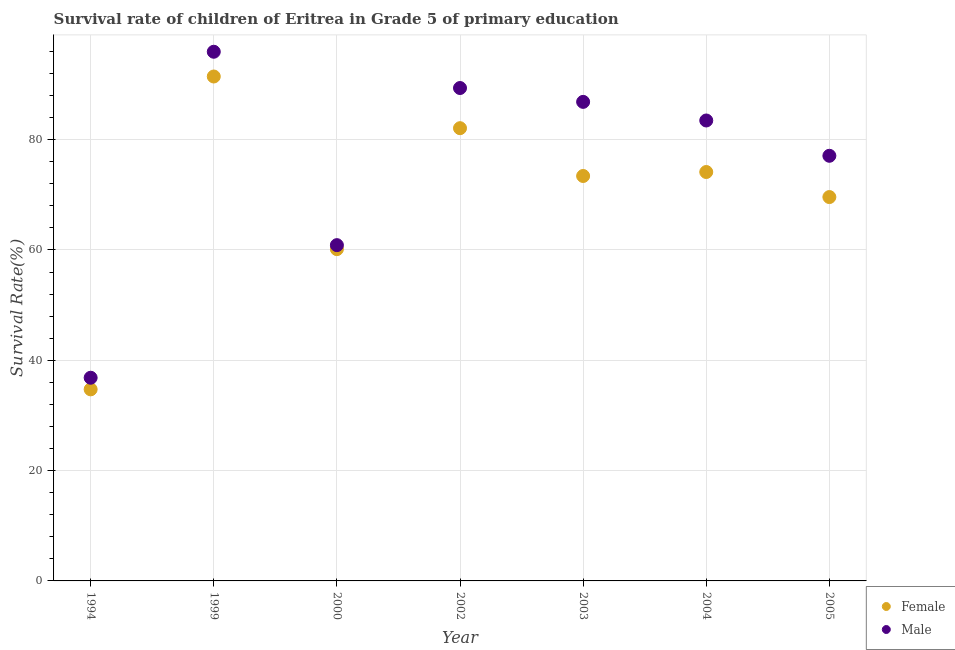What is the survival rate of female students in primary education in 2004?
Give a very brief answer. 74.13. Across all years, what is the maximum survival rate of male students in primary education?
Offer a terse response. 95.94. Across all years, what is the minimum survival rate of male students in primary education?
Your response must be concise. 36.84. What is the total survival rate of male students in primary education in the graph?
Offer a terse response. 530.41. What is the difference between the survival rate of male students in primary education in 2003 and that in 2005?
Provide a short and direct response. 9.77. What is the difference between the survival rate of female students in primary education in 2003 and the survival rate of male students in primary education in 1994?
Your answer should be compact. 36.58. What is the average survival rate of female students in primary education per year?
Provide a succinct answer. 69.36. In the year 1994, what is the difference between the survival rate of female students in primary education and survival rate of male students in primary education?
Provide a succinct answer. -2.1. In how many years, is the survival rate of male students in primary education greater than 12 %?
Your response must be concise. 7. What is the ratio of the survival rate of male students in primary education in 1994 to that in 2003?
Keep it short and to the point. 0.42. Is the difference between the survival rate of male students in primary education in 2000 and 2003 greater than the difference between the survival rate of female students in primary education in 2000 and 2003?
Your response must be concise. No. What is the difference between the highest and the second highest survival rate of male students in primary education?
Make the answer very short. 6.58. What is the difference between the highest and the lowest survival rate of female students in primary education?
Provide a short and direct response. 56.72. How many dotlines are there?
Provide a succinct answer. 2. How many years are there in the graph?
Provide a short and direct response. 7. What is the difference between two consecutive major ticks on the Y-axis?
Offer a very short reply. 20. Does the graph contain grids?
Ensure brevity in your answer.  Yes. How many legend labels are there?
Ensure brevity in your answer.  2. How are the legend labels stacked?
Offer a terse response. Vertical. What is the title of the graph?
Provide a short and direct response. Survival rate of children of Eritrea in Grade 5 of primary education. Does "Techinal cooperation" appear as one of the legend labels in the graph?
Provide a short and direct response. No. What is the label or title of the X-axis?
Provide a succinct answer. Year. What is the label or title of the Y-axis?
Give a very brief answer. Survival Rate(%). What is the Survival Rate(%) of Female in 1994?
Make the answer very short. 34.73. What is the Survival Rate(%) in Male in 1994?
Keep it short and to the point. 36.84. What is the Survival Rate(%) of Female in 1999?
Your response must be concise. 91.45. What is the Survival Rate(%) in Male in 1999?
Your answer should be very brief. 95.94. What is the Survival Rate(%) of Female in 2000?
Offer a very short reply. 60.15. What is the Survival Rate(%) in Male in 2000?
Your answer should be very brief. 60.88. What is the Survival Rate(%) of Female in 2002?
Ensure brevity in your answer.  82.08. What is the Survival Rate(%) of Male in 2002?
Provide a succinct answer. 89.36. What is the Survival Rate(%) in Female in 2003?
Provide a short and direct response. 73.41. What is the Survival Rate(%) in Male in 2003?
Offer a terse response. 86.85. What is the Survival Rate(%) in Female in 2004?
Offer a very short reply. 74.13. What is the Survival Rate(%) in Male in 2004?
Provide a short and direct response. 83.48. What is the Survival Rate(%) of Female in 2005?
Give a very brief answer. 69.59. What is the Survival Rate(%) of Male in 2005?
Your response must be concise. 77.08. Across all years, what is the maximum Survival Rate(%) in Female?
Make the answer very short. 91.45. Across all years, what is the maximum Survival Rate(%) of Male?
Make the answer very short. 95.94. Across all years, what is the minimum Survival Rate(%) in Female?
Offer a very short reply. 34.73. Across all years, what is the minimum Survival Rate(%) of Male?
Provide a short and direct response. 36.84. What is the total Survival Rate(%) in Female in the graph?
Give a very brief answer. 485.55. What is the total Survival Rate(%) of Male in the graph?
Ensure brevity in your answer.  530.41. What is the difference between the Survival Rate(%) of Female in 1994 and that in 1999?
Offer a terse response. -56.72. What is the difference between the Survival Rate(%) in Male in 1994 and that in 1999?
Provide a succinct answer. -59.1. What is the difference between the Survival Rate(%) of Female in 1994 and that in 2000?
Keep it short and to the point. -25.42. What is the difference between the Survival Rate(%) of Male in 1994 and that in 2000?
Offer a very short reply. -24.04. What is the difference between the Survival Rate(%) of Female in 1994 and that in 2002?
Your answer should be compact. -47.35. What is the difference between the Survival Rate(%) of Male in 1994 and that in 2002?
Ensure brevity in your answer.  -52.53. What is the difference between the Survival Rate(%) of Female in 1994 and that in 2003?
Your answer should be very brief. -38.68. What is the difference between the Survival Rate(%) of Male in 1994 and that in 2003?
Offer a terse response. -50.01. What is the difference between the Survival Rate(%) in Female in 1994 and that in 2004?
Make the answer very short. -39.4. What is the difference between the Survival Rate(%) in Male in 1994 and that in 2004?
Offer a very short reply. -46.64. What is the difference between the Survival Rate(%) in Female in 1994 and that in 2005?
Your answer should be very brief. -34.86. What is the difference between the Survival Rate(%) of Male in 1994 and that in 2005?
Your response must be concise. -40.24. What is the difference between the Survival Rate(%) of Female in 1999 and that in 2000?
Provide a short and direct response. 31.3. What is the difference between the Survival Rate(%) of Male in 1999 and that in 2000?
Ensure brevity in your answer.  35.06. What is the difference between the Survival Rate(%) in Female in 1999 and that in 2002?
Provide a succinct answer. 9.37. What is the difference between the Survival Rate(%) of Male in 1999 and that in 2002?
Your response must be concise. 6.58. What is the difference between the Survival Rate(%) of Female in 1999 and that in 2003?
Provide a short and direct response. 18.04. What is the difference between the Survival Rate(%) of Male in 1999 and that in 2003?
Your answer should be very brief. 9.09. What is the difference between the Survival Rate(%) of Female in 1999 and that in 2004?
Your answer should be compact. 17.32. What is the difference between the Survival Rate(%) of Male in 1999 and that in 2004?
Your response must be concise. 12.46. What is the difference between the Survival Rate(%) in Female in 1999 and that in 2005?
Ensure brevity in your answer.  21.86. What is the difference between the Survival Rate(%) in Male in 1999 and that in 2005?
Your answer should be very brief. 18.86. What is the difference between the Survival Rate(%) of Female in 2000 and that in 2002?
Offer a very short reply. -21.93. What is the difference between the Survival Rate(%) of Male in 2000 and that in 2002?
Offer a very short reply. -28.49. What is the difference between the Survival Rate(%) of Female in 2000 and that in 2003?
Keep it short and to the point. -13.26. What is the difference between the Survival Rate(%) in Male in 2000 and that in 2003?
Keep it short and to the point. -25.97. What is the difference between the Survival Rate(%) of Female in 2000 and that in 2004?
Provide a succinct answer. -13.98. What is the difference between the Survival Rate(%) of Male in 2000 and that in 2004?
Provide a short and direct response. -22.6. What is the difference between the Survival Rate(%) in Female in 2000 and that in 2005?
Your answer should be compact. -9.44. What is the difference between the Survival Rate(%) in Male in 2000 and that in 2005?
Keep it short and to the point. -16.2. What is the difference between the Survival Rate(%) in Female in 2002 and that in 2003?
Provide a succinct answer. 8.67. What is the difference between the Survival Rate(%) of Male in 2002 and that in 2003?
Ensure brevity in your answer.  2.51. What is the difference between the Survival Rate(%) in Female in 2002 and that in 2004?
Make the answer very short. 7.95. What is the difference between the Survival Rate(%) in Male in 2002 and that in 2004?
Your answer should be very brief. 5.89. What is the difference between the Survival Rate(%) in Female in 2002 and that in 2005?
Your response must be concise. 12.49. What is the difference between the Survival Rate(%) in Male in 2002 and that in 2005?
Your response must be concise. 12.29. What is the difference between the Survival Rate(%) of Female in 2003 and that in 2004?
Your response must be concise. -0.72. What is the difference between the Survival Rate(%) of Male in 2003 and that in 2004?
Ensure brevity in your answer.  3.37. What is the difference between the Survival Rate(%) of Female in 2003 and that in 2005?
Provide a succinct answer. 3.82. What is the difference between the Survival Rate(%) in Male in 2003 and that in 2005?
Give a very brief answer. 9.77. What is the difference between the Survival Rate(%) of Female in 2004 and that in 2005?
Offer a terse response. 4.54. What is the difference between the Survival Rate(%) in Male in 2004 and that in 2005?
Your response must be concise. 6.4. What is the difference between the Survival Rate(%) of Female in 1994 and the Survival Rate(%) of Male in 1999?
Ensure brevity in your answer.  -61.2. What is the difference between the Survival Rate(%) in Female in 1994 and the Survival Rate(%) in Male in 2000?
Provide a short and direct response. -26.14. What is the difference between the Survival Rate(%) in Female in 1994 and the Survival Rate(%) in Male in 2002?
Give a very brief answer. -54.63. What is the difference between the Survival Rate(%) of Female in 1994 and the Survival Rate(%) of Male in 2003?
Offer a very short reply. -52.12. What is the difference between the Survival Rate(%) in Female in 1994 and the Survival Rate(%) in Male in 2004?
Keep it short and to the point. -48.74. What is the difference between the Survival Rate(%) in Female in 1994 and the Survival Rate(%) in Male in 2005?
Offer a very short reply. -42.34. What is the difference between the Survival Rate(%) of Female in 1999 and the Survival Rate(%) of Male in 2000?
Give a very brief answer. 30.57. What is the difference between the Survival Rate(%) in Female in 1999 and the Survival Rate(%) in Male in 2002?
Ensure brevity in your answer.  2.09. What is the difference between the Survival Rate(%) of Female in 1999 and the Survival Rate(%) of Male in 2003?
Provide a short and direct response. 4.6. What is the difference between the Survival Rate(%) in Female in 1999 and the Survival Rate(%) in Male in 2004?
Provide a short and direct response. 7.97. What is the difference between the Survival Rate(%) in Female in 1999 and the Survival Rate(%) in Male in 2005?
Your answer should be compact. 14.37. What is the difference between the Survival Rate(%) of Female in 2000 and the Survival Rate(%) of Male in 2002?
Keep it short and to the point. -29.21. What is the difference between the Survival Rate(%) in Female in 2000 and the Survival Rate(%) in Male in 2003?
Your answer should be very brief. -26.7. What is the difference between the Survival Rate(%) in Female in 2000 and the Survival Rate(%) in Male in 2004?
Offer a very short reply. -23.33. What is the difference between the Survival Rate(%) of Female in 2000 and the Survival Rate(%) of Male in 2005?
Your response must be concise. -16.93. What is the difference between the Survival Rate(%) of Female in 2002 and the Survival Rate(%) of Male in 2003?
Ensure brevity in your answer.  -4.77. What is the difference between the Survival Rate(%) of Female in 2002 and the Survival Rate(%) of Male in 2004?
Offer a terse response. -1.4. What is the difference between the Survival Rate(%) of Female in 2002 and the Survival Rate(%) of Male in 2005?
Give a very brief answer. 5. What is the difference between the Survival Rate(%) of Female in 2003 and the Survival Rate(%) of Male in 2004?
Give a very brief answer. -10.06. What is the difference between the Survival Rate(%) of Female in 2003 and the Survival Rate(%) of Male in 2005?
Your response must be concise. -3.66. What is the difference between the Survival Rate(%) of Female in 2004 and the Survival Rate(%) of Male in 2005?
Offer a very short reply. -2.94. What is the average Survival Rate(%) in Female per year?
Keep it short and to the point. 69.36. What is the average Survival Rate(%) in Male per year?
Your answer should be compact. 75.77. In the year 1994, what is the difference between the Survival Rate(%) in Female and Survival Rate(%) in Male?
Ensure brevity in your answer.  -2.1. In the year 1999, what is the difference between the Survival Rate(%) of Female and Survival Rate(%) of Male?
Provide a succinct answer. -4.49. In the year 2000, what is the difference between the Survival Rate(%) of Female and Survival Rate(%) of Male?
Provide a succinct answer. -0.73. In the year 2002, what is the difference between the Survival Rate(%) in Female and Survival Rate(%) in Male?
Provide a succinct answer. -7.28. In the year 2003, what is the difference between the Survival Rate(%) in Female and Survival Rate(%) in Male?
Give a very brief answer. -13.44. In the year 2004, what is the difference between the Survival Rate(%) in Female and Survival Rate(%) in Male?
Offer a very short reply. -9.34. In the year 2005, what is the difference between the Survival Rate(%) in Female and Survival Rate(%) in Male?
Your response must be concise. -7.48. What is the ratio of the Survival Rate(%) of Female in 1994 to that in 1999?
Your answer should be compact. 0.38. What is the ratio of the Survival Rate(%) of Male in 1994 to that in 1999?
Make the answer very short. 0.38. What is the ratio of the Survival Rate(%) in Female in 1994 to that in 2000?
Provide a succinct answer. 0.58. What is the ratio of the Survival Rate(%) of Male in 1994 to that in 2000?
Provide a succinct answer. 0.61. What is the ratio of the Survival Rate(%) in Female in 1994 to that in 2002?
Provide a succinct answer. 0.42. What is the ratio of the Survival Rate(%) in Male in 1994 to that in 2002?
Provide a short and direct response. 0.41. What is the ratio of the Survival Rate(%) in Female in 1994 to that in 2003?
Ensure brevity in your answer.  0.47. What is the ratio of the Survival Rate(%) in Male in 1994 to that in 2003?
Offer a very short reply. 0.42. What is the ratio of the Survival Rate(%) in Female in 1994 to that in 2004?
Your answer should be very brief. 0.47. What is the ratio of the Survival Rate(%) in Male in 1994 to that in 2004?
Ensure brevity in your answer.  0.44. What is the ratio of the Survival Rate(%) in Female in 1994 to that in 2005?
Offer a very short reply. 0.5. What is the ratio of the Survival Rate(%) of Male in 1994 to that in 2005?
Keep it short and to the point. 0.48. What is the ratio of the Survival Rate(%) of Female in 1999 to that in 2000?
Your answer should be compact. 1.52. What is the ratio of the Survival Rate(%) of Male in 1999 to that in 2000?
Offer a very short reply. 1.58. What is the ratio of the Survival Rate(%) in Female in 1999 to that in 2002?
Provide a succinct answer. 1.11. What is the ratio of the Survival Rate(%) in Male in 1999 to that in 2002?
Provide a short and direct response. 1.07. What is the ratio of the Survival Rate(%) of Female in 1999 to that in 2003?
Give a very brief answer. 1.25. What is the ratio of the Survival Rate(%) of Male in 1999 to that in 2003?
Your answer should be compact. 1.1. What is the ratio of the Survival Rate(%) of Female in 1999 to that in 2004?
Make the answer very short. 1.23. What is the ratio of the Survival Rate(%) in Male in 1999 to that in 2004?
Ensure brevity in your answer.  1.15. What is the ratio of the Survival Rate(%) in Female in 1999 to that in 2005?
Ensure brevity in your answer.  1.31. What is the ratio of the Survival Rate(%) in Male in 1999 to that in 2005?
Provide a succinct answer. 1.24. What is the ratio of the Survival Rate(%) of Female in 2000 to that in 2002?
Your answer should be very brief. 0.73. What is the ratio of the Survival Rate(%) of Male in 2000 to that in 2002?
Your response must be concise. 0.68. What is the ratio of the Survival Rate(%) of Female in 2000 to that in 2003?
Give a very brief answer. 0.82. What is the ratio of the Survival Rate(%) in Male in 2000 to that in 2003?
Keep it short and to the point. 0.7. What is the ratio of the Survival Rate(%) of Female in 2000 to that in 2004?
Ensure brevity in your answer.  0.81. What is the ratio of the Survival Rate(%) in Male in 2000 to that in 2004?
Your answer should be very brief. 0.73. What is the ratio of the Survival Rate(%) of Female in 2000 to that in 2005?
Provide a succinct answer. 0.86. What is the ratio of the Survival Rate(%) in Male in 2000 to that in 2005?
Make the answer very short. 0.79. What is the ratio of the Survival Rate(%) of Female in 2002 to that in 2003?
Keep it short and to the point. 1.12. What is the ratio of the Survival Rate(%) of Male in 2002 to that in 2003?
Offer a terse response. 1.03. What is the ratio of the Survival Rate(%) in Female in 2002 to that in 2004?
Offer a terse response. 1.11. What is the ratio of the Survival Rate(%) in Male in 2002 to that in 2004?
Keep it short and to the point. 1.07. What is the ratio of the Survival Rate(%) in Female in 2002 to that in 2005?
Offer a very short reply. 1.18. What is the ratio of the Survival Rate(%) of Male in 2002 to that in 2005?
Keep it short and to the point. 1.16. What is the ratio of the Survival Rate(%) in Female in 2003 to that in 2004?
Keep it short and to the point. 0.99. What is the ratio of the Survival Rate(%) in Male in 2003 to that in 2004?
Offer a terse response. 1.04. What is the ratio of the Survival Rate(%) in Female in 2003 to that in 2005?
Your answer should be compact. 1.05. What is the ratio of the Survival Rate(%) in Male in 2003 to that in 2005?
Give a very brief answer. 1.13. What is the ratio of the Survival Rate(%) of Female in 2004 to that in 2005?
Ensure brevity in your answer.  1.07. What is the ratio of the Survival Rate(%) in Male in 2004 to that in 2005?
Keep it short and to the point. 1.08. What is the difference between the highest and the second highest Survival Rate(%) in Female?
Ensure brevity in your answer.  9.37. What is the difference between the highest and the second highest Survival Rate(%) in Male?
Ensure brevity in your answer.  6.58. What is the difference between the highest and the lowest Survival Rate(%) of Female?
Keep it short and to the point. 56.72. What is the difference between the highest and the lowest Survival Rate(%) in Male?
Offer a very short reply. 59.1. 